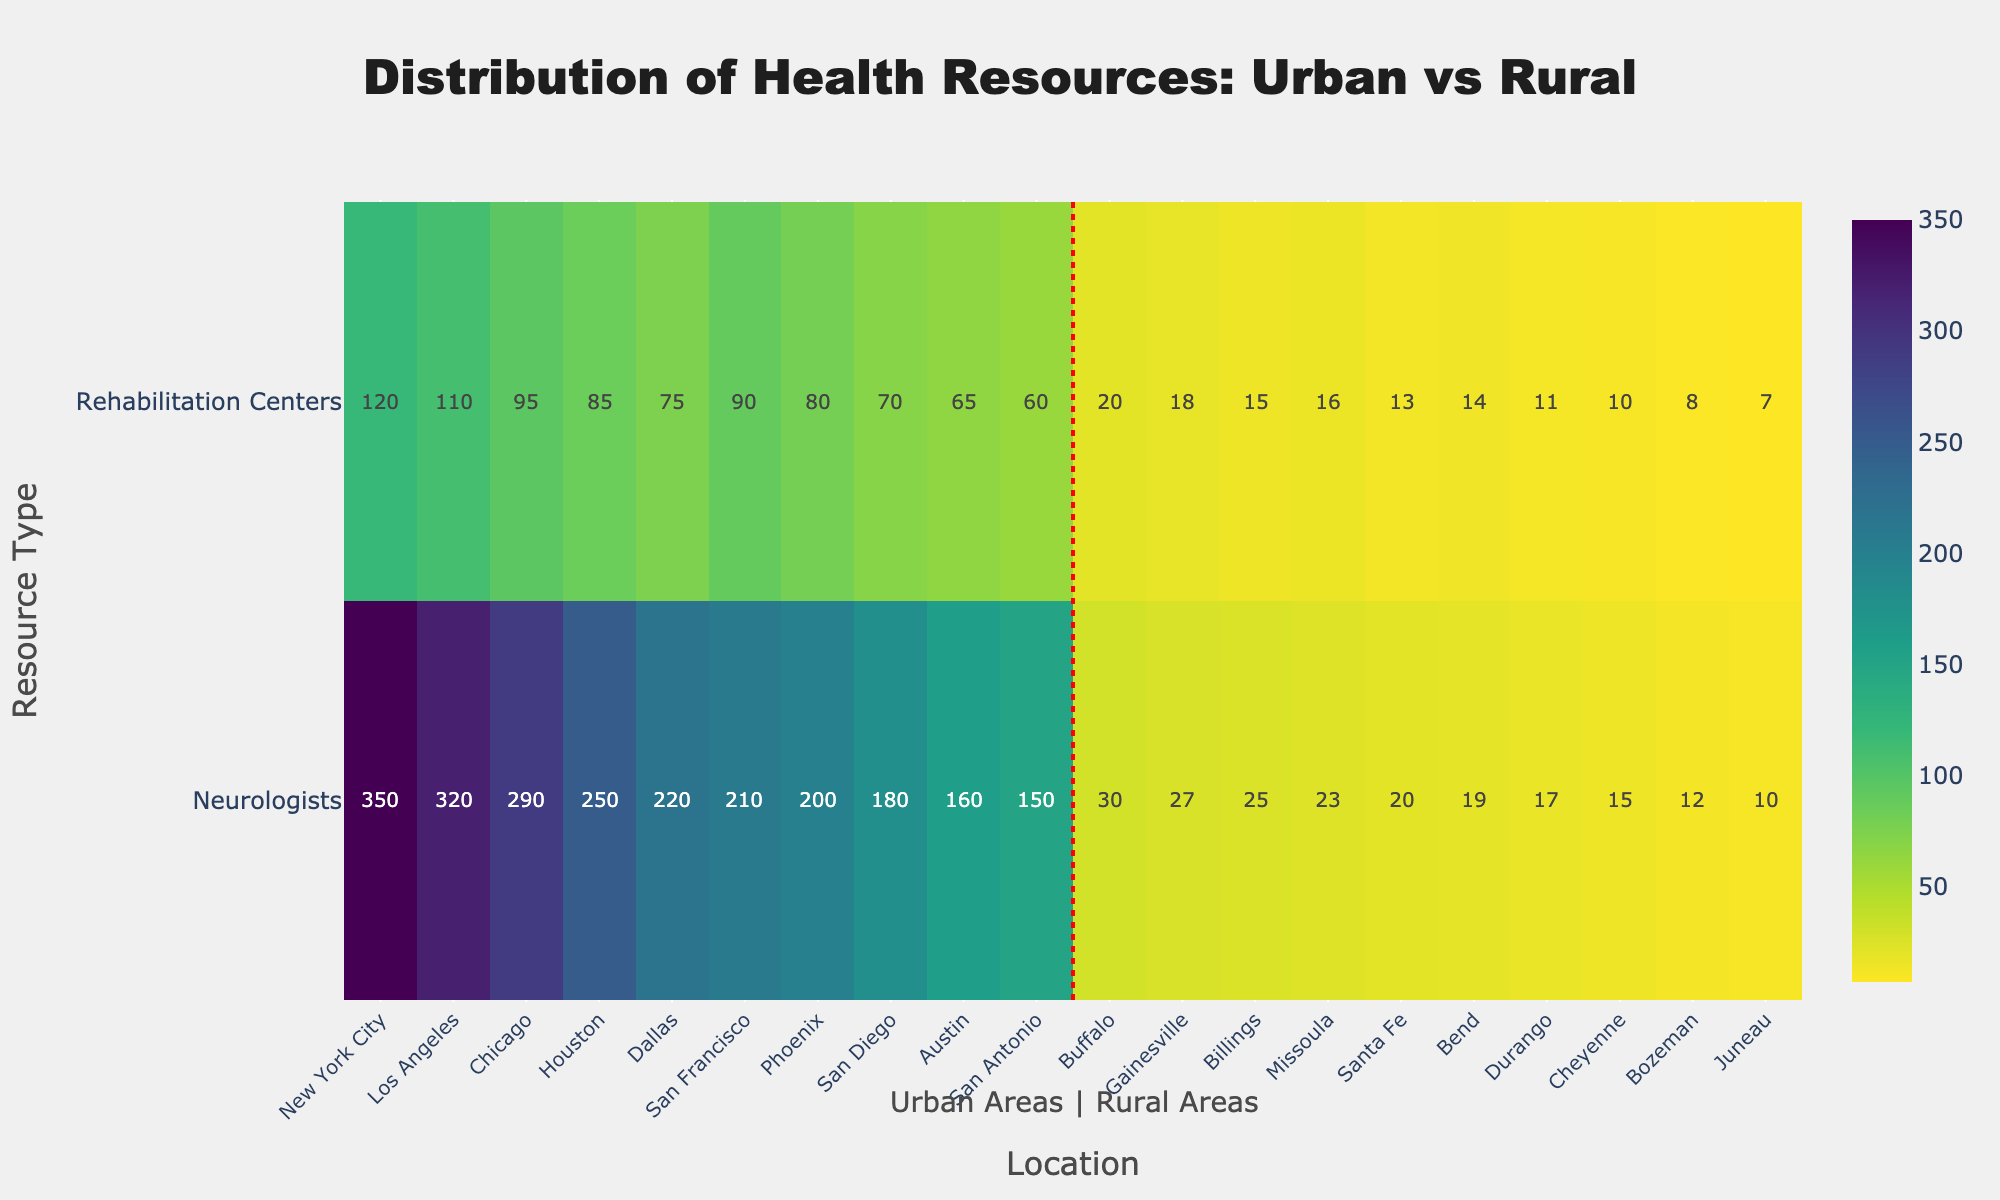Which urban location has the highest number of neurologists? Look at the urban locations listed in the heatmap; New York City has the highest number of neurologists with 350.
Answer: New York City What is the total number of rehabilitation centers in rural areas? Sum the number of rehabilitation centers in the rural areas; the total is (20 + 10 + 15 + 13 + 7 + 8 + 11 + 14 + 16 + 18) = 132.
Answer: 132 How many more neurologists are there in Phoenix compared to Juneau? Subtract the number of neurologists in Juneau from the number in Phoenix; it is 200 - 10 = 190.
Answer: 190 Which has fewer rehabilitation centers, Dallas or Cheyenne, and by how many? Compare Dallas and Cheyenne; Dallas has 75 and Cheyenne has 10, so Dallas has 75 - 10 = 65 more.
Answer: Cheyenne by 65 Are there any rural locations with more than 25 neurologists? Examine the neurologist counts for rural locations in the heatmap; only Gainesville has more than 25 neurologists with 27.
Answer: Yes, Gainesville What is the average number of neurologists in urban locations? Sum the number of neurologists in urban locations and divide by the number of urban locations; (350 + 320 + 290 + 250 + 200 + 150 + 180 + 220 + 160 + 210) / 10 = 233
Answer: 233 Between urban and rural areas, which region generally has more rehabilitation centers? Compare the number of rehabilitation centers across both regions and observe that urban areas generally have more rehabilitation centers.
Answer: Urban How many rehabilitation centers are there in both Dallas and Los Angeles combined? Add the number of rehabilitation centers in Dallas and Los Angeles; 75 + 110 = 185.
Answer: 185 Which location has the lowest number of neurologists overall? Look for the location with the least number of neurologists in the heatmap; Juneau has the lowest with 10.
Answer: Juneau Is there a significant difference in the distribution of neurologists between urban and rural areas? Compare the distribution of neurologists in both regions; urban areas generally have significantly more neurologists compared to rural areas.
Answer: Yes 